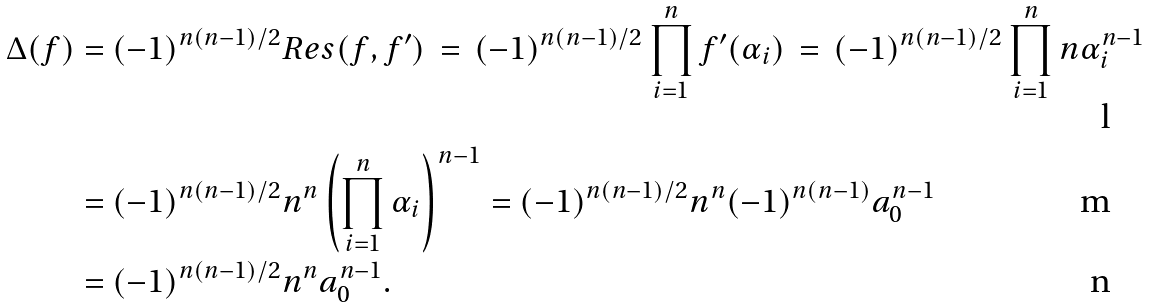<formula> <loc_0><loc_0><loc_500><loc_500>\Delta ( f ) & = ( - 1 ) ^ { n ( n - 1 ) / 2 } R e s ( f , f ^ { \prime } ) \, = \, ( - 1 ) ^ { n ( n - 1 ) / 2 } \prod _ { i = 1 } ^ { n } f ^ { \prime } ( \alpha _ { i } ) \, = \, ( - 1 ) ^ { n ( n - 1 ) / 2 } \prod _ { i = 1 } ^ { n } n \alpha _ { i } ^ { n - 1 } \\ & = ( - 1 ) ^ { n ( n - 1 ) / 2 } n ^ { n } \left ( \prod _ { i = 1 } ^ { n } \alpha _ { i } \right ) ^ { n - 1 } = ( - 1 ) ^ { n ( n - 1 ) / 2 } n ^ { n } ( - 1 ) ^ { n ( n - 1 ) } a _ { 0 } ^ { n - 1 } \\ & = ( - 1 ) ^ { n ( n - 1 ) / 2 } n ^ { n } a _ { 0 } ^ { n - 1 } .</formula> 